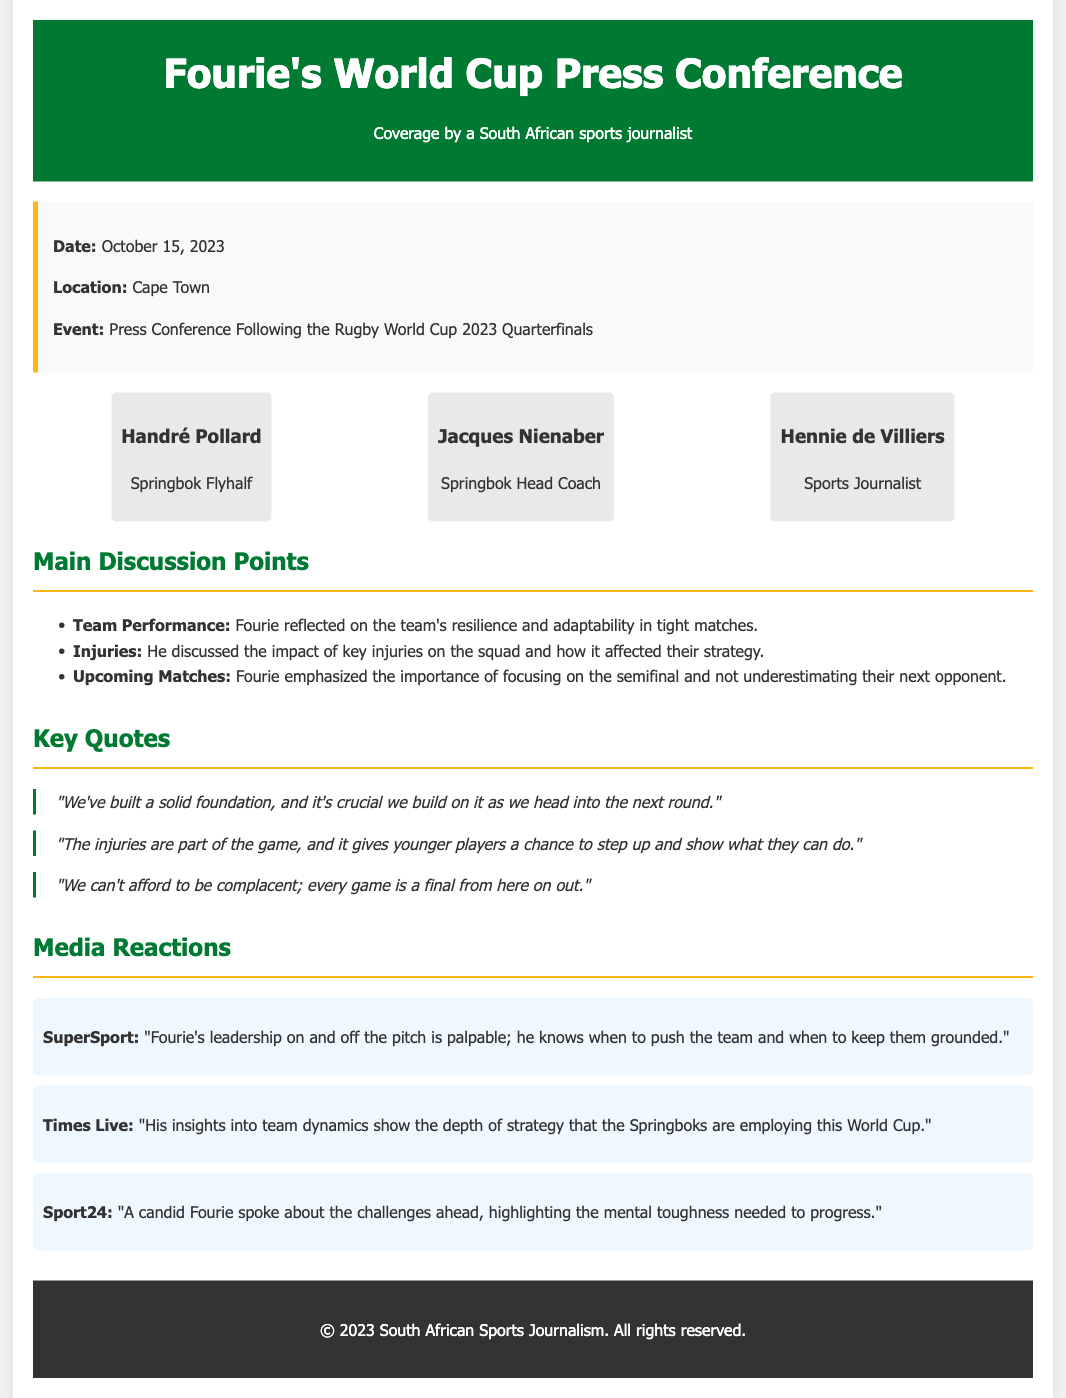What date was the press conference held? The date of the press conference is specifically mentioned in the document as October 15, 2023.
Answer: October 15, 2023 Where did the press conference take place? The location of the event is specified as Cape Town in the document.
Answer: Cape Town Who is the Springbok head coach mentioned in the document? The document lists Jacques Nienaber as the Springbok Head Coach.
Answer: Jacques Nienaber What key message did Fourie emphasize regarding the upcoming matches? The document highlights that Fourie emphasized the importance of focusing on the semifinal and not underestimating their next opponent.
Answer: Importance of focusing on the semifinal Which media outlet mentioned Fourie's leadership qualities? SuperSport commented on Fourie's leadership on and off the pitch in the media reactions.
Answer: SuperSport How many main discussion points are listed in the document? The document contains three main discussion points discussed by Fourie.
Answer: Three What effect do injuries have on the Springbok squad according to Fourie? Fourie noted that injuries give younger players a chance to step up and show what they can do.
Answer: Gives younger players a chance What was a notable quote from Fourie regarding the team's foundation? One of the quotes from Fourie states that they have built a solid foundation, which is crucial to build on.
Answer: "We've built a solid foundation" Which publication highlighted Fourie’s insights into team dynamics? Times Live emphasized Fourie's insights into team dynamics in the media reactions section.
Answer: Times Live 